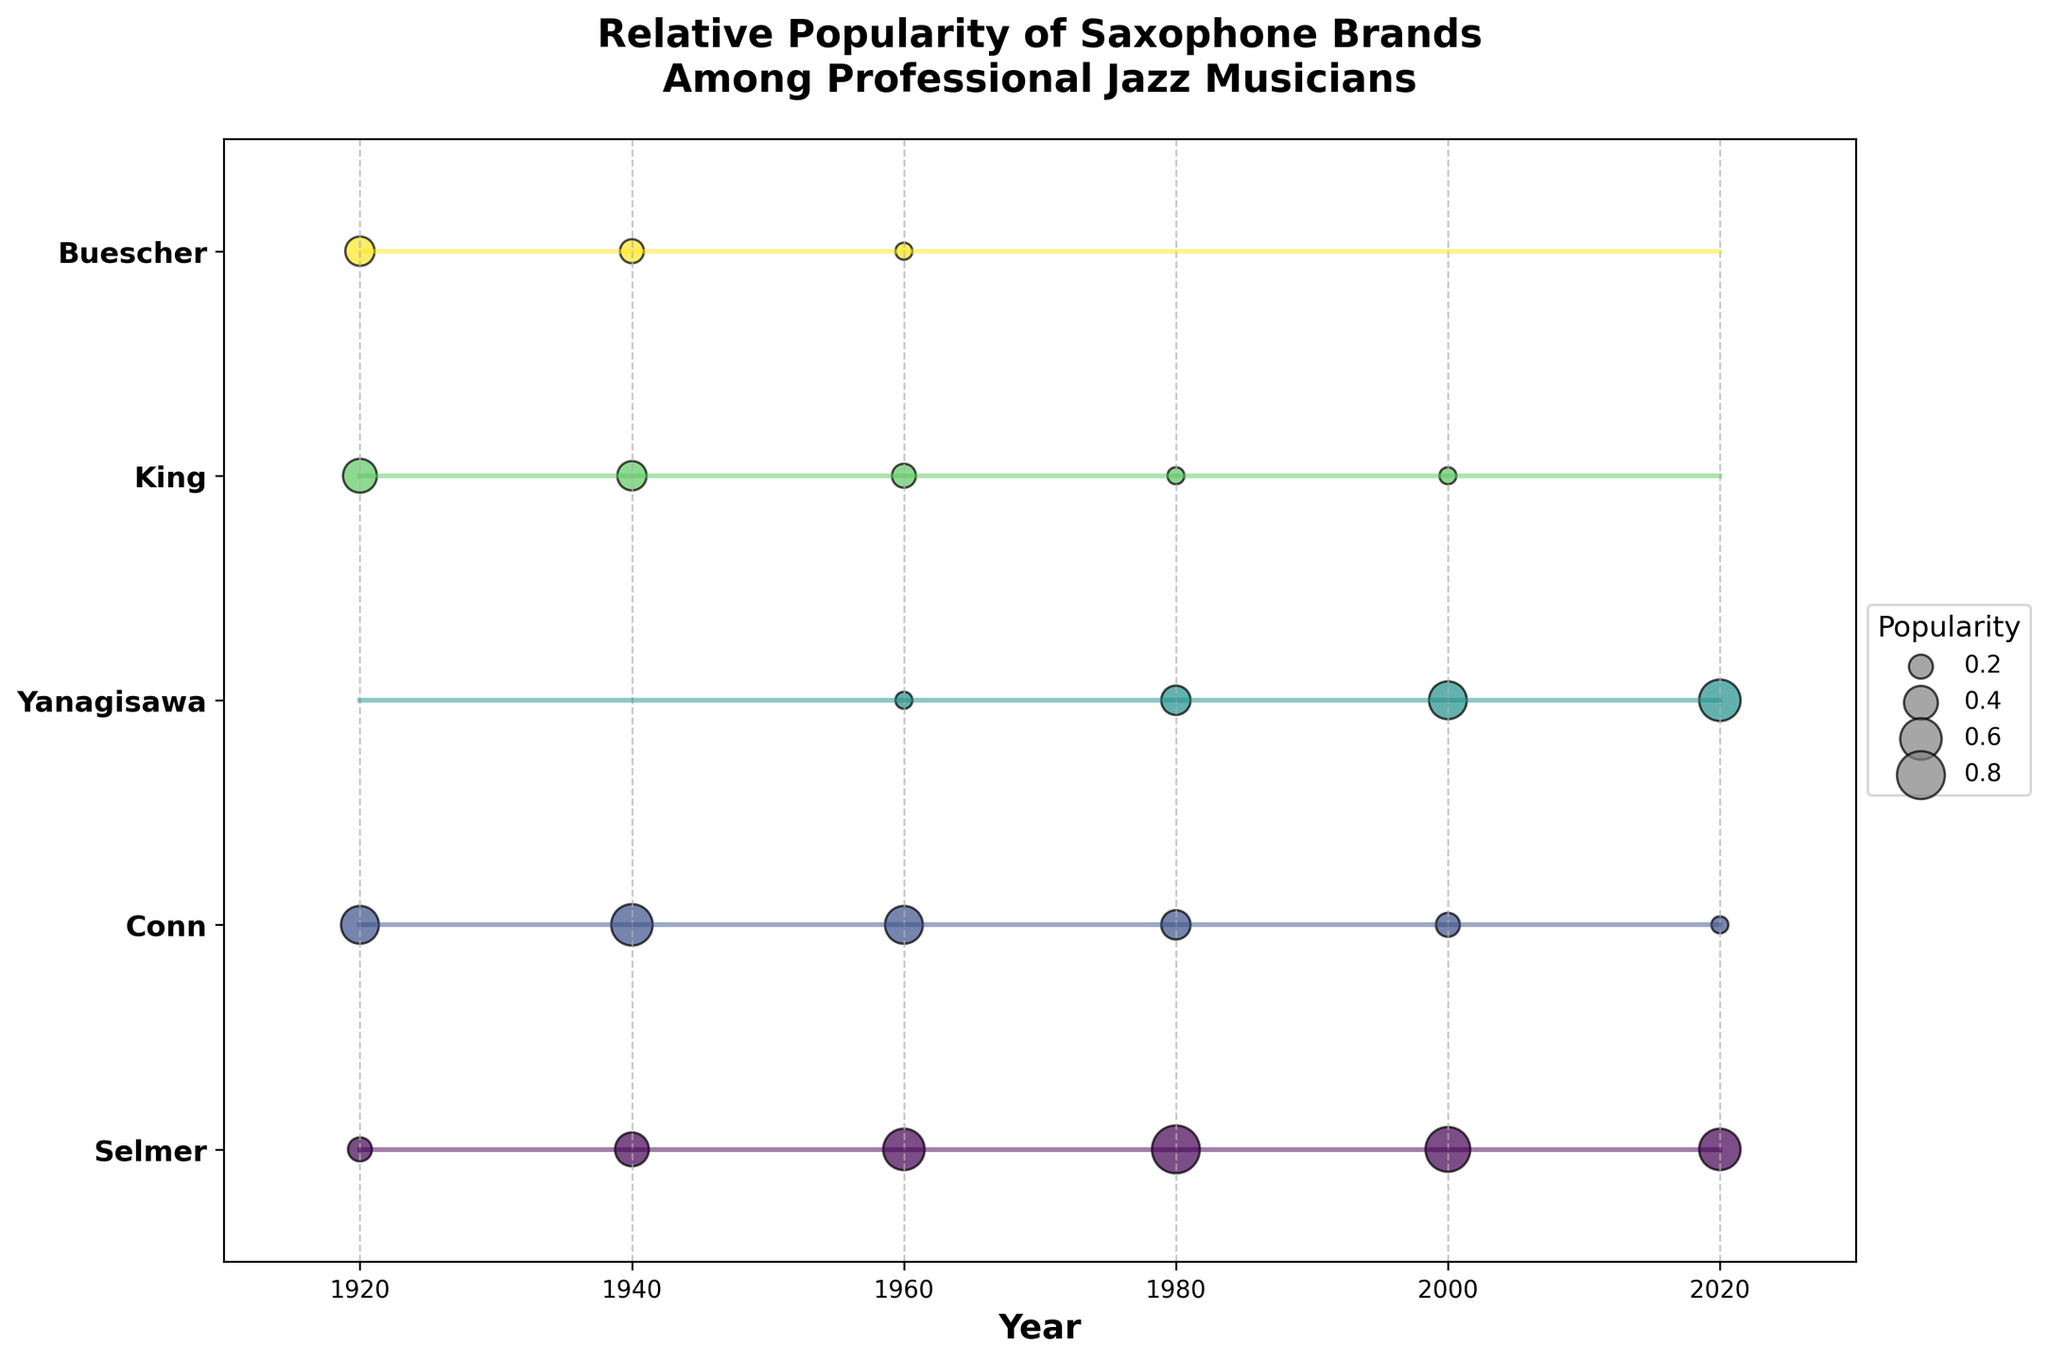How many saxophone brands are compared in the figure? To answer this, count the number of unique brand names plotted on the y-axis. There are five distinct brands (Selmer, Conn, Yanagisawa, King, and Buescher).
Answer: Five What is the title of the figure? The title is displayed at the top of the figure. It reads "Relative Popularity of Saxophone Brands Among Professional Jazz Musicians."
Answer: Relative Popularity of Saxophone Brands Among Professional Jazz Musicians Which saxophone brand shows a steady increase in popularity from the 1920s to 2020? By observing the trend lines and bubble sizes over the years, it is evident that Yanagisawa shows a steady increase from 0.0 in 1920 to 0.6 in 2020.
Answer: Yanagisawa Between which years did Conn saxophones see the biggest decrease in popularity? Looking at the plotted values for Conn, the most significant drop occurs between 1960 (0.5) and 1980 (0.3). Hence, this indicates the most considerable decrease in popularity.
Answer: 1960 to 1980 Which brand had the highest peak in popularity, and when did it occur? To find the peak popularity, observe the size of the bubbles. The largest bubble appears for Selmer in 1980 with a popularity of 0.8.
Answer: Selmer in 1980 Compare the popularity of Conn saxophones in 1940 with that in 2020. By looking at the scatter plots for Conn, we see that in 1940 the popularity is 0.6 and in 2020 it is 0.1. Conn's popularity in 1940 was significantly higher than in 2020.
Answer: Higher in 1940 Which brand(s) had no popularity in both the 1920s and the 1940s? Identifying the brands with 0.0 popularity for both the years. Only Yanagisawa had 0.0 popularity in both 1920 and 1940.
Answer: Yanagisawa Which saxophone brand shows a decline in popularity starting from the 1980s onward? By analyzing the trend lines, Buescher shows a clear decline from 1980 onwards, reaching 0.0 by 2000 and 2020.
Answer: Buescher What is the average popularity of King saxophones across the entire time period? Calculating the average value for the plotted popularity values for King (0.4, 0.3, 0.2, 0.1, 0.1, 0.0). (0.4 + 0.3 + 0.2 + 0.1 + 0.1 + 0.0) / 6 = 0.1833
Answer: 0.18 